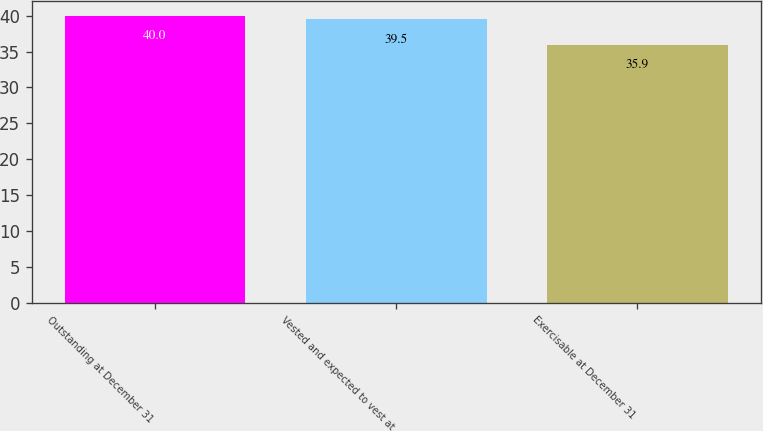<chart> <loc_0><loc_0><loc_500><loc_500><bar_chart><fcel>Outstanding at December 31<fcel>Vested and expected to vest at<fcel>Exercisable at December 31<nl><fcel>40<fcel>39.5<fcel>35.9<nl></chart> 